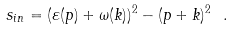<formula> <loc_0><loc_0><loc_500><loc_500>s _ { i n } = ( \varepsilon ( { p } ) + \omega ( { k } ) ) ^ { 2 } - ( { p } + { k } ) ^ { 2 } \ .</formula> 